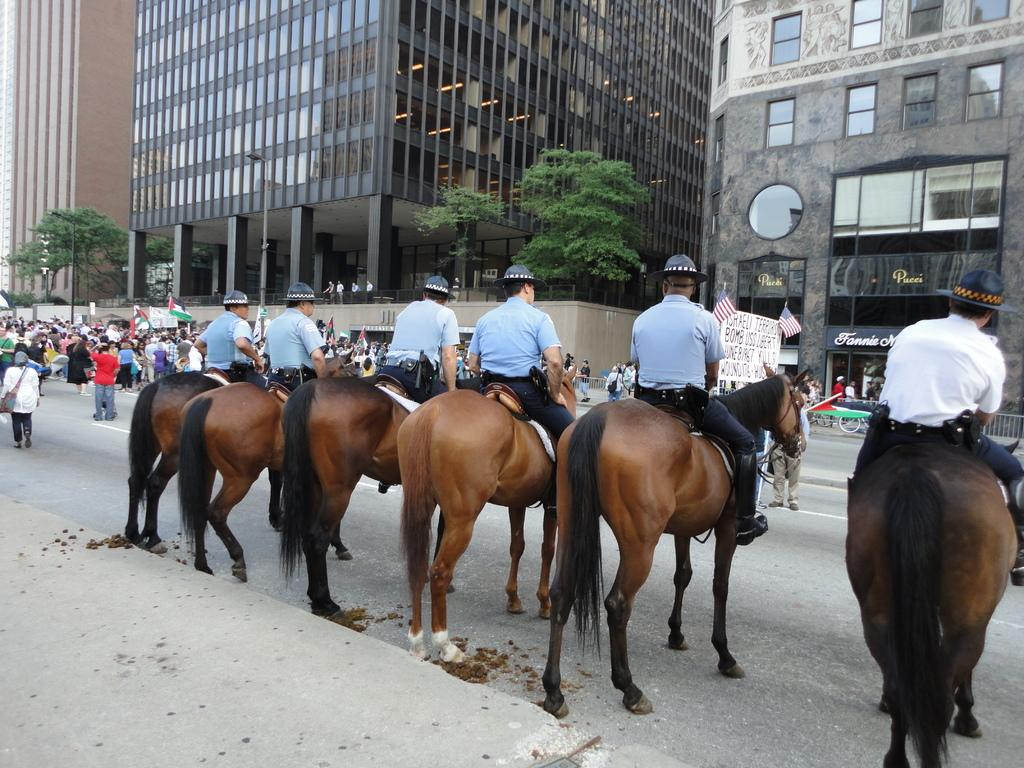What are the main subjects in the image? There is a group of people on horses in the image. Are there any other people in the image? Yes, there are people standing on the side in the image. What can be seen in the background of the image? There are buildings and trees visible in the image. What type of cloth is being used to create a rhythm in the image? There is no cloth or rhythm present in the image; it features a group of people on horses and people standing on the side, with buildings and trees in the background. 